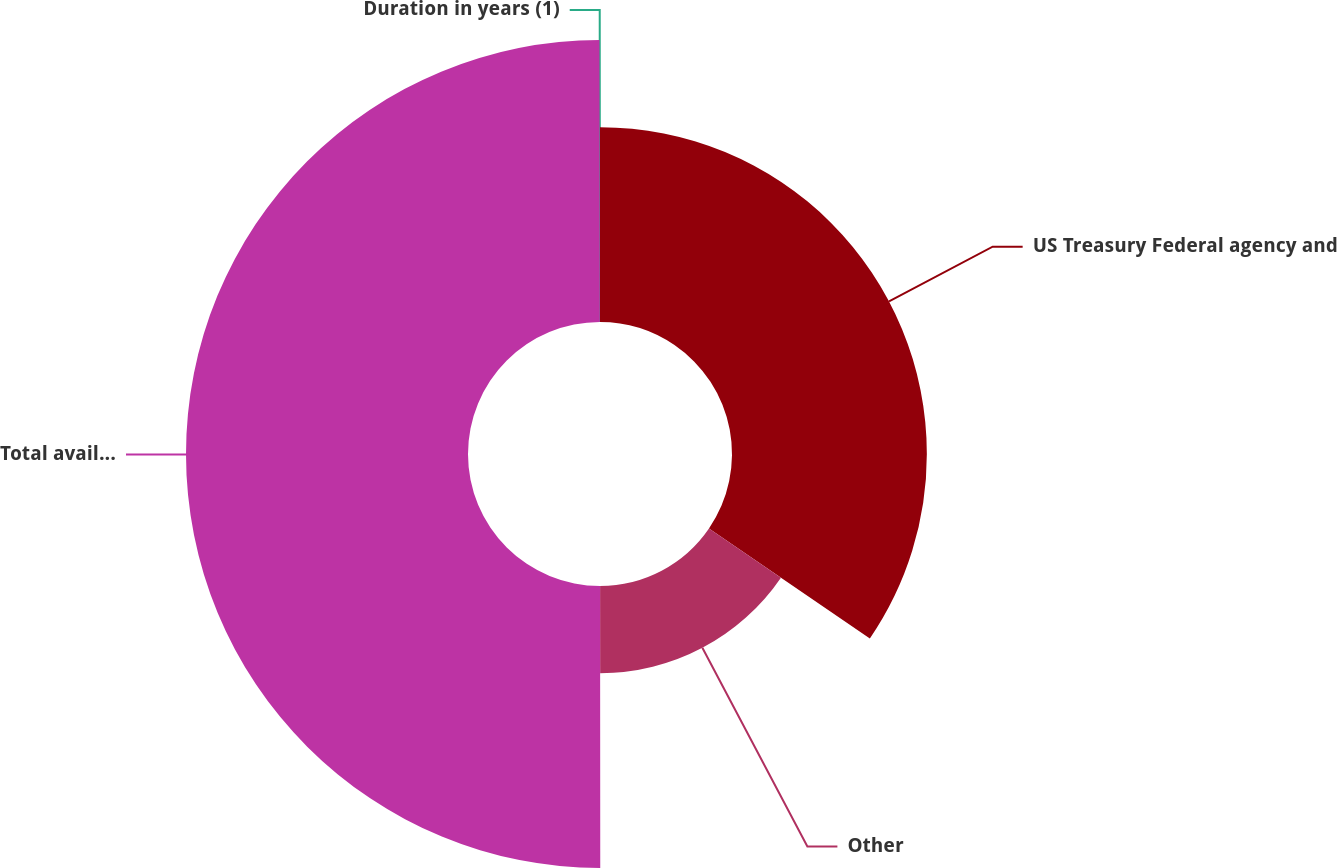Convert chart. <chart><loc_0><loc_0><loc_500><loc_500><pie_chart><fcel>US Treasury Federal agency and<fcel>Other<fcel>Total available-for-sale and<fcel>Duration in years (1)<nl><fcel>34.54%<fcel>15.45%<fcel>49.99%<fcel>0.02%<nl></chart> 